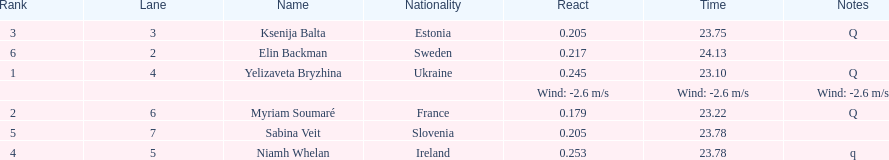How long did it take elin backman to finish the race? 24.13. 